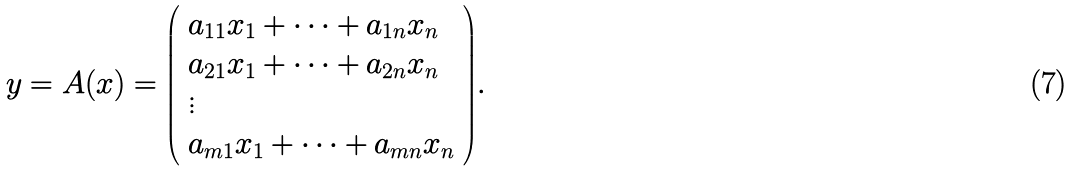Convert formula to latex. <formula><loc_0><loc_0><loc_500><loc_500>y = A ( x ) = { \left ( \begin{array} { l } { a _ { 1 1 } x _ { 1 } + \cdots + a _ { 1 n } x _ { n } } \\ { a _ { 2 1 } x _ { 1 } + \cdots + a _ { 2 n } x _ { n } } \\ { \vdots } \\ { a _ { m 1 } x _ { 1 } + \cdots + a _ { m n } x _ { n } } \end{array} \right ) } .</formula> 